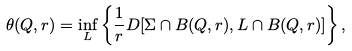Convert formula to latex. <formula><loc_0><loc_0><loc_500><loc_500>\theta ( Q , r ) = \inf _ { L } \left \{ \frac { 1 } { r } D [ \Sigma \cap B ( Q , r ) , L \cap B ( Q , r ) ] \right \} ,</formula> 